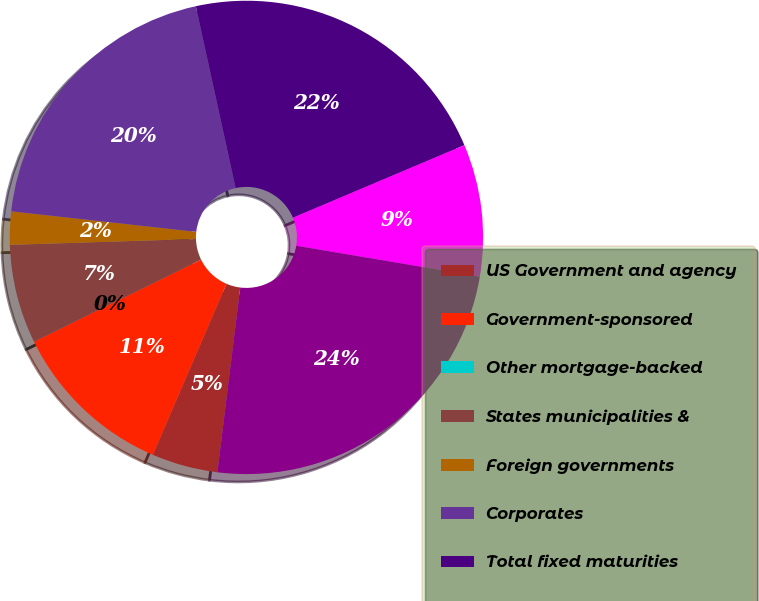Convert chart to OTSL. <chart><loc_0><loc_0><loc_500><loc_500><pie_chart><fcel>US Government and agency<fcel>Government-sponsored<fcel>Other mortgage-backed<fcel>States municipalities &<fcel>Foreign governments<fcel>Corporates<fcel>Total fixed maturities<fcel>Equities<fcel>Total<nl><fcel>4.51%<fcel>11.27%<fcel>0.0%<fcel>6.76%<fcel>2.26%<fcel>19.81%<fcel>22.06%<fcel>9.02%<fcel>24.31%<nl></chart> 